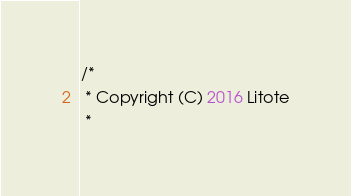<code> <loc_0><loc_0><loc_500><loc_500><_Kotlin_>/*
 * Copyright (C) 2016 Litote
 *</code> 